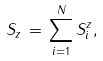Convert formula to latex. <formula><loc_0><loc_0><loc_500><loc_500>S _ { z } \, = \, \sum _ { i = 1 } ^ { N } S _ { i } ^ { z } ,</formula> 